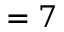Convert formula to latex. <formula><loc_0><loc_0><loc_500><loc_500>= 7</formula> 